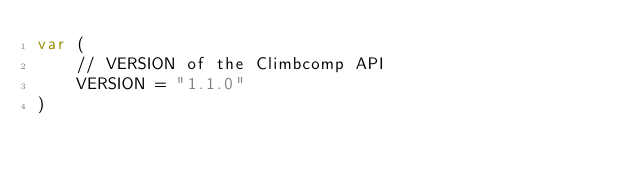<code> <loc_0><loc_0><loc_500><loc_500><_Go_>var (
	// VERSION of the Climbcomp API
	VERSION = "1.1.0"
)
</code> 